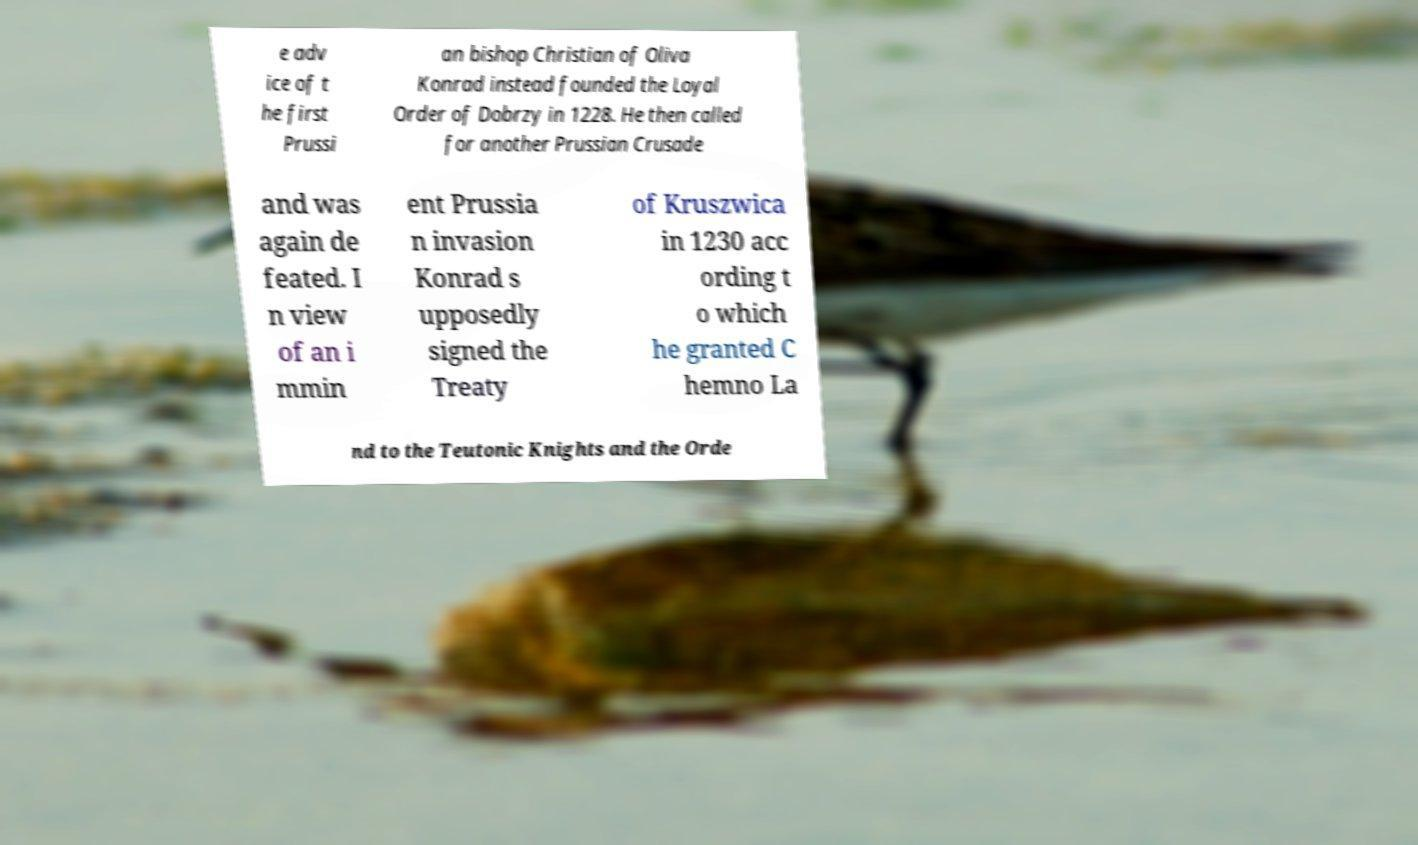Please read and relay the text visible in this image. What does it say? e adv ice of t he first Prussi an bishop Christian of Oliva Konrad instead founded the Loyal Order of Dobrzy in 1228. He then called for another Prussian Crusade and was again de feated. I n view of an i mmin ent Prussia n invasion Konrad s upposedly signed the Treaty of Kruszwica in 1230 acc ording t o which he granted C hemno La nd to the Teutonic Knights and the Orde 